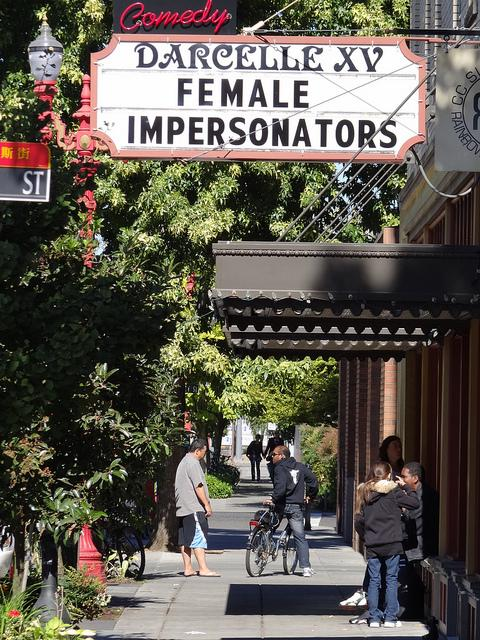Why do they impersonate females? Please explain your reasoning. money. The sign is at a store. 